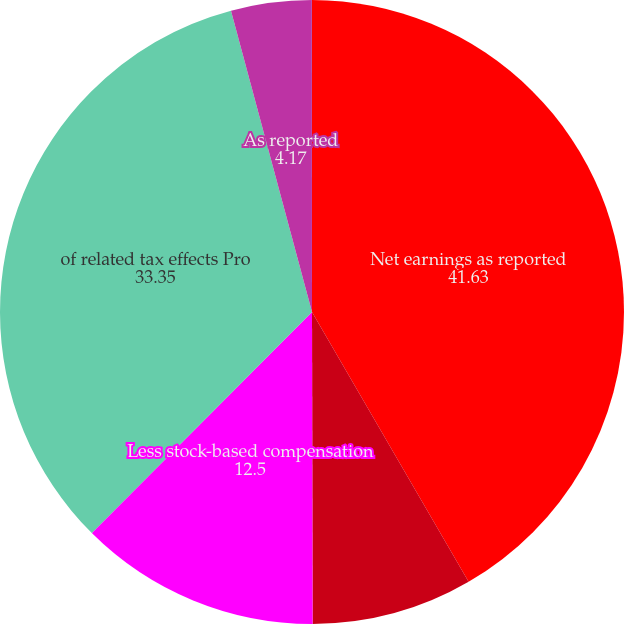Convert chart to OTSL. <chart><loc_0><loc_0><loc_500><loc_500><pie_chart><fcel>Net earnings as reported<fcel>Add stock-based compensation<fcel>Less stock-based compensation<fcel>of related tax effects Pro<fcel>As reported<fcel>Pro forma<nl><fcel>41.63%<fcel>8.34%<fcel>12.5%<fcel>33.35%<fcel>4.17%<fcel>0.01%<nl></chart> 